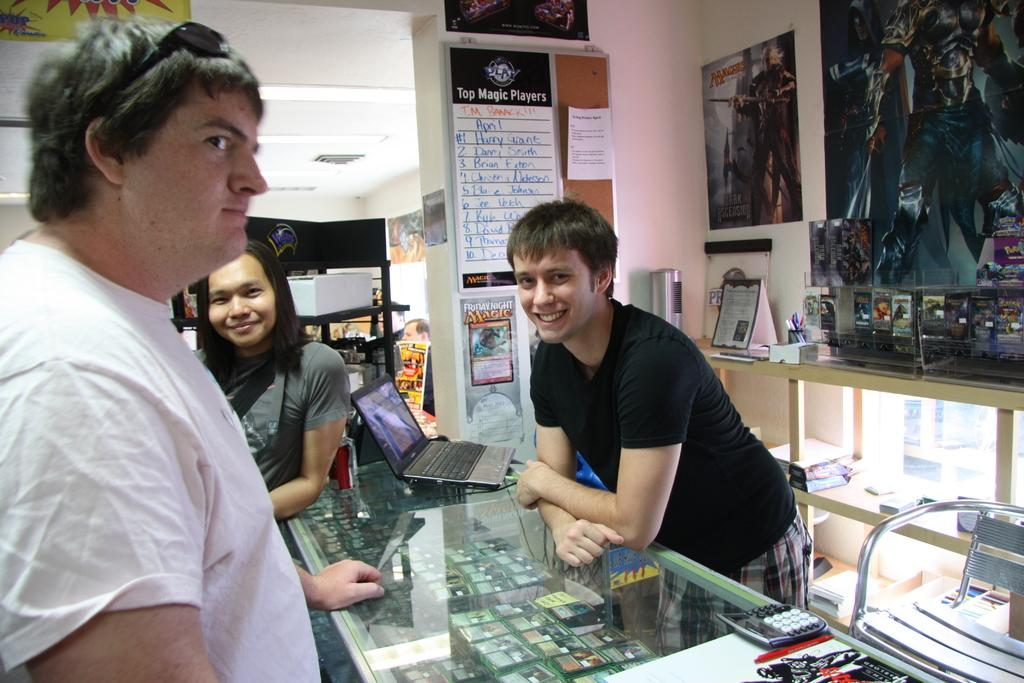What can be seen in the image? There are people standing in the image. What type of furniture is present in the image? There is a glass table in the image. What decorations are on the wall in the image? There are posters attached to the wall in the image. What type of poison is being used by the woman in the image? There is no woman or poison present in the image. What type of stove is visible in the image? There is no stove present in the image. 